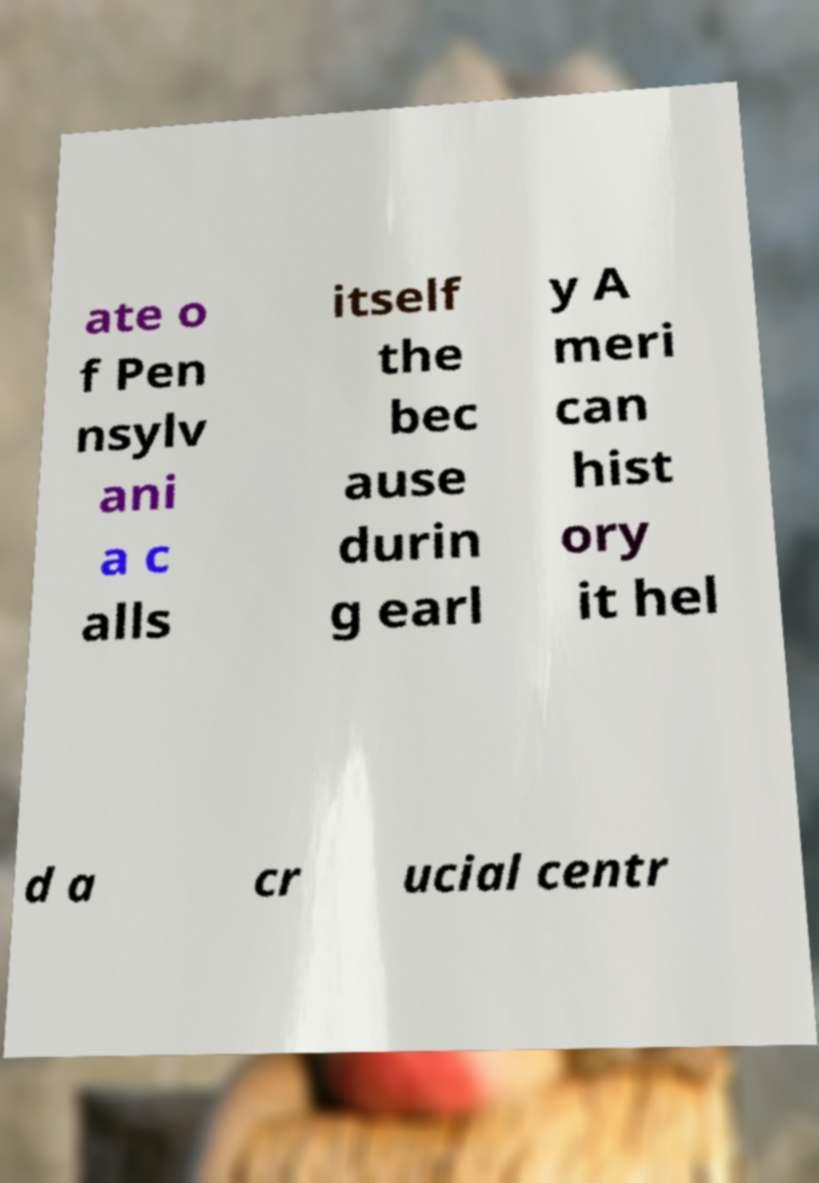Could you extract and type out the text from this image? ate o f Pen nsylv ani a c alls itself the bec ause durin g earl y A meri can hist ory it hel d a cr ucial centr 